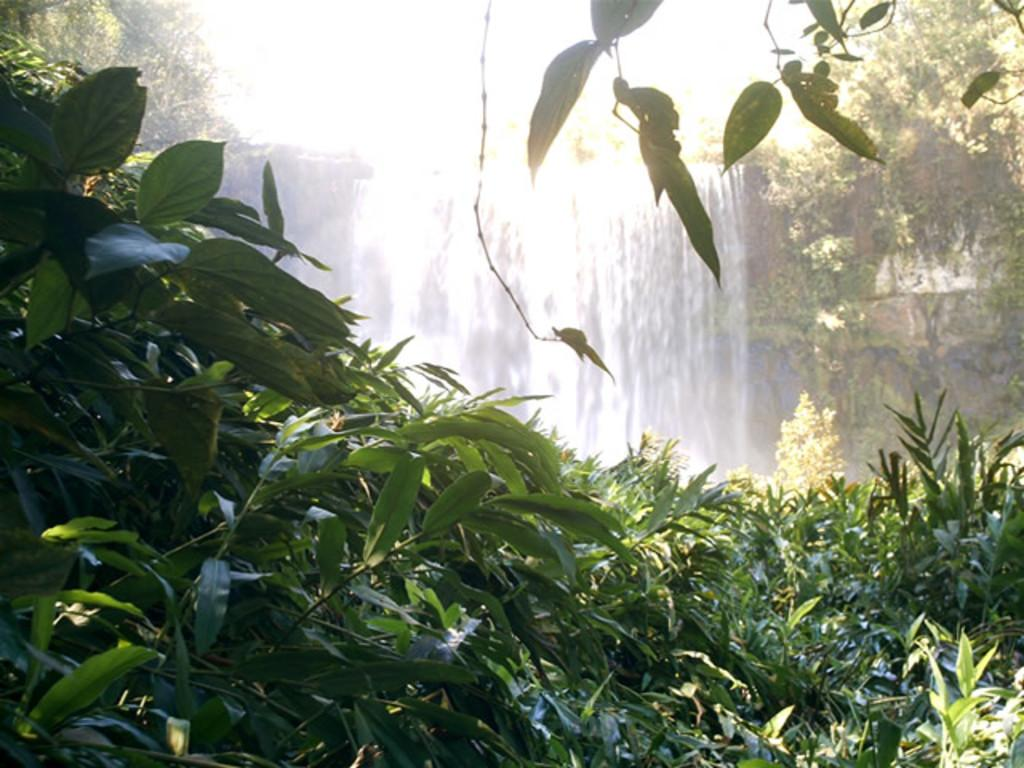What natural feature is the main subject of the image? There is a waterfall in the image. What type of vegetation can be seen in the image? There are plants and trees in the image. What type of comb is being used to groom the pig in the image? There is no pig or comb present in the image; it features a waterfall and vegetation. 